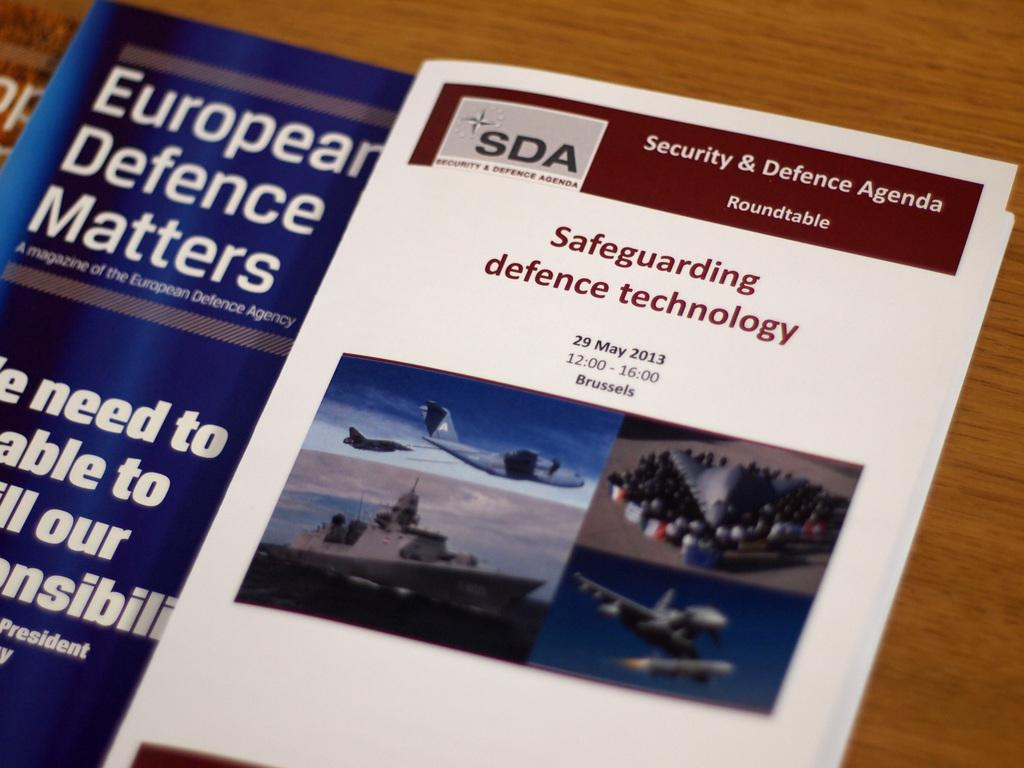Provide a one-sentence caption for the provided image. An open pamphlet that says Safeguarding defence technology from 2013. 